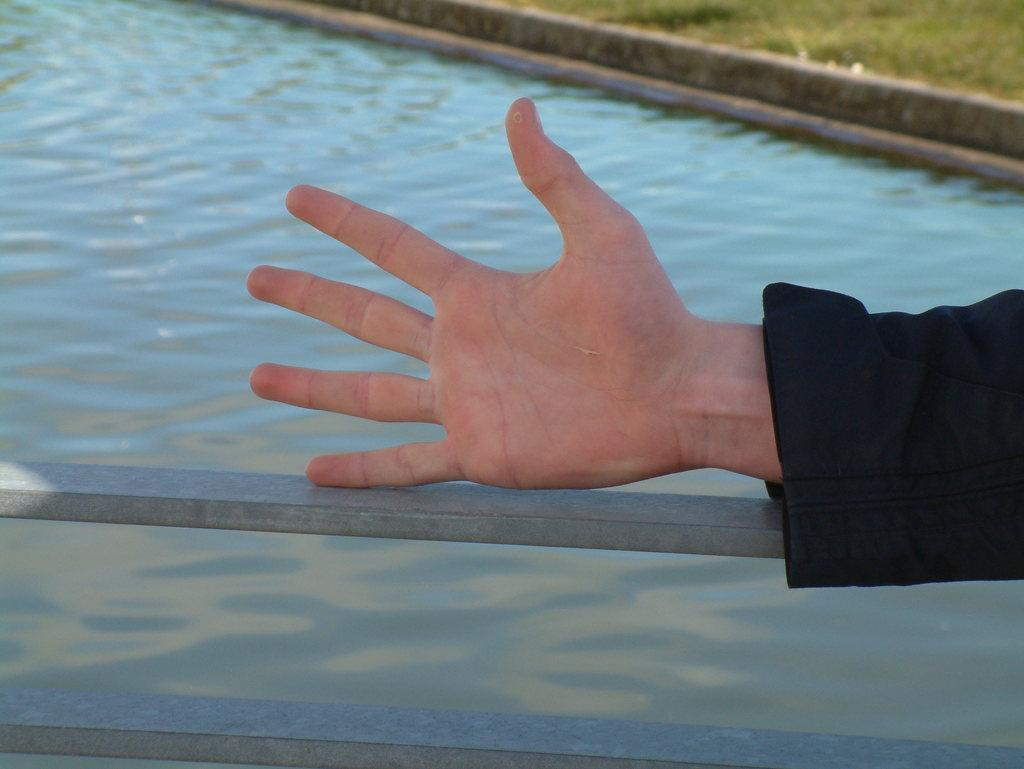What part of a person can be seen in the image? There is a person's hand in the image. What can be seen in the background of the image? Water and metal rods are visible in the background of the image. How many goldfish can be seen swimming in the water in the image? There are no goldfish visible in the image; only water and metal rods can be seen in the background. Are there any cherries or fairies present in the image? No, there are no cherries or fairies present in the image. 